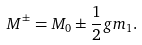<formula> <loc_0><loc_0><loc_500><loc_500>M ^ { \pm } = M _ { 0 } \pm \frac { 1 } { 2 } g m _ { 1 } .</formula> 